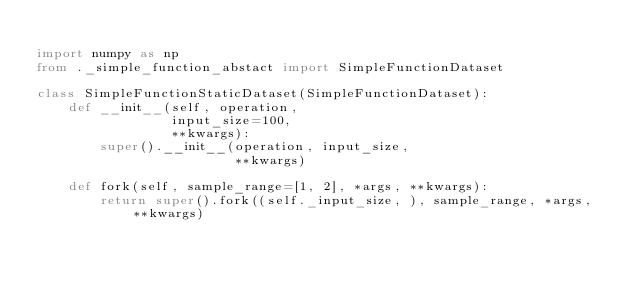Convert code to text. <code><loc_0><loc_0><loc_500><loc_500><_Python_>
import numpy as np
from ._simple_function_abstact import SimpleFunctionDataset

class SimpleFunctionStaticDataset(SimpleFunctionDataset):
    def __init__(self, operation,
                 input_size=100,
                 **kwargs):
        super().__init__(operation, input_size,
                         **kwargs)

    def fork(self, sample_range=[1, 2], *args, **kwargs):
        return super().fork((self._input_size, ), sample_range, *args, **kwargs)
</code> 